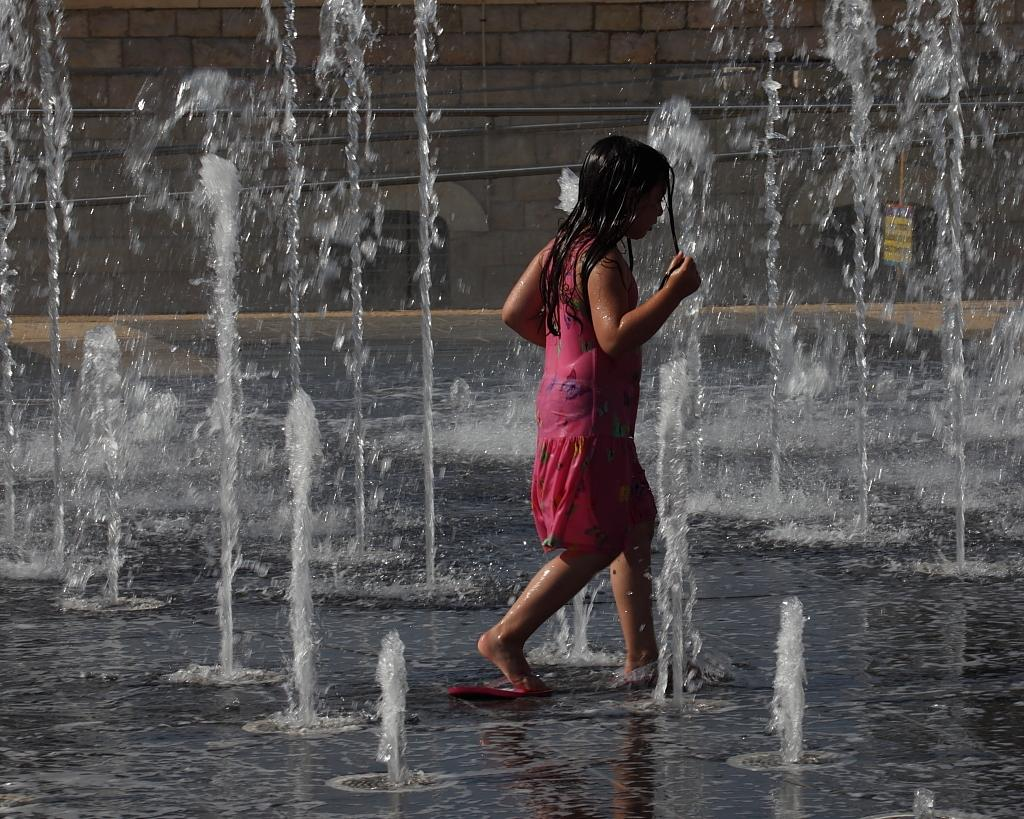Who is the main subject in the image? There is a girl in the image. What is the girl doing in the image? The girl is playing in a water fountain. What is the girl wearing in the image? The girl is wearing a pink dress. What can be seen behind the water fountain in the image? There is a brick wall behind the water fountain. Can you see any salt on the girl's dress in the image? There is no salt visible on the girl's dress in the image. 